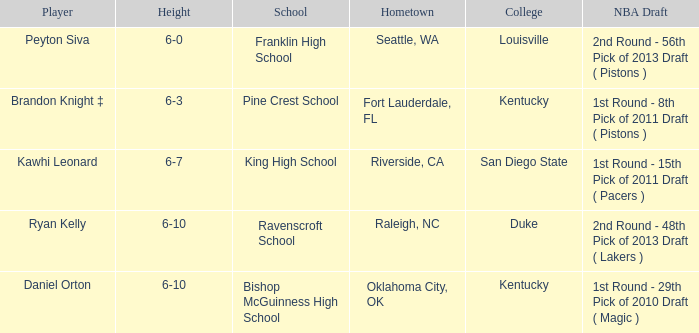What is the height of daniel orton? 6-10. 